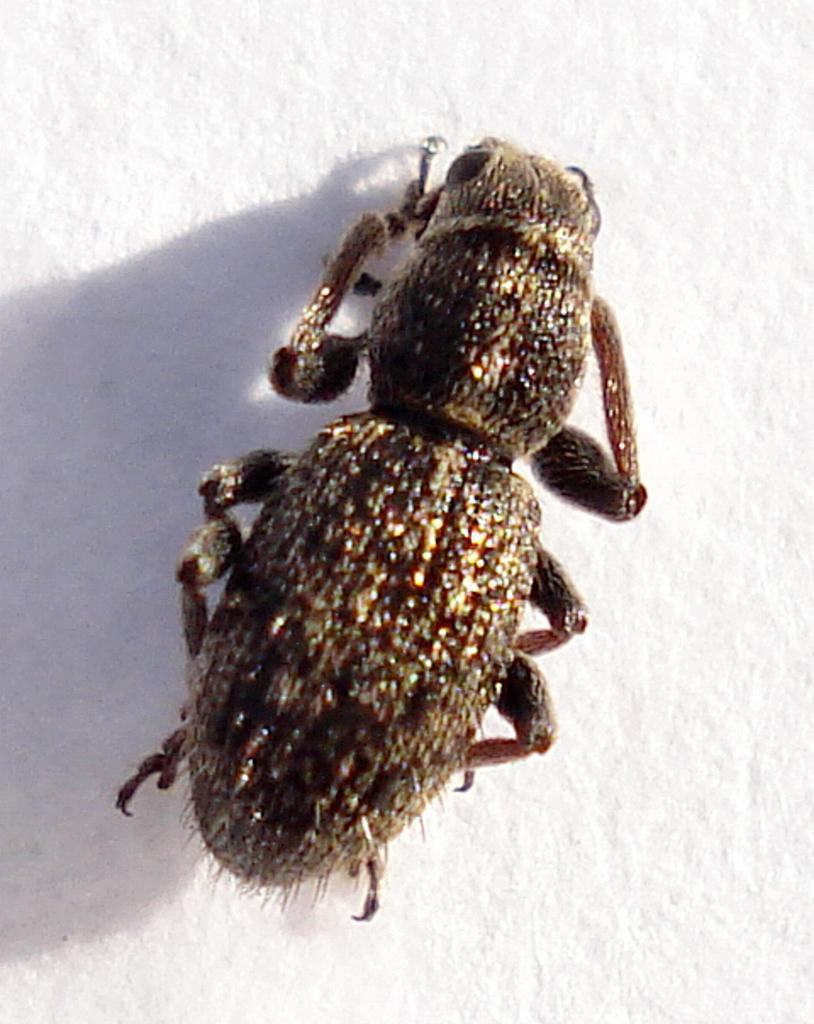What type of creature can be seen in the image? There is an insect present in the image. Where is the insect located in the image? The insect is on the surface of something in the center of the image. What type of rhythm can be heard from the cattle in the image? There are no cattle present in the image, and therefore no rhythm can be heard. 